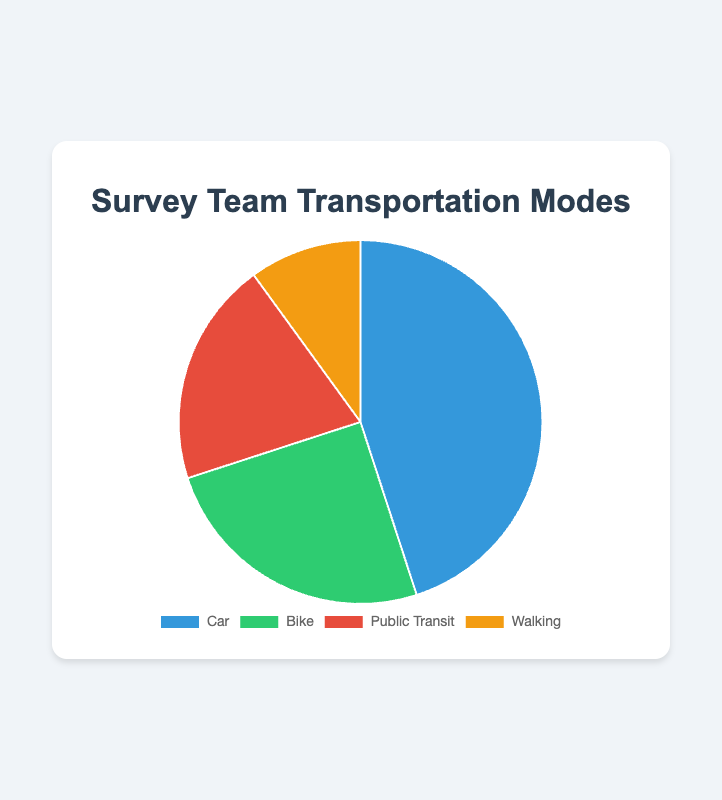What percentage of the survey teams use bicycles or walk for transportation? We need to add the percentages for "Bike" and "Walking". "Bike" accounts for 25% and "Walking" accounts for 10%. Adding these together gives us 25% + 10% = 35%.
Answer: 35% Which mode of transportation is most commonly used by the survey teams? The pie chart shows different modes of transportation with their respective percentages. The highest percentage corresponds to "Car" with 45%.
Answer: Car Are there more survey teams using public transit or walking? We compare the percentages for "Public Transit" and "Walking". "Public Transit" has 20%, while "Walking" has 10%. Since 20% is greater than 10%, more teams use public transit than walking.
Answer: Public Transit How much more popular is using a car compared to using a bike? We need to subtract the percentage of teams using a bike from those using a car. For "Car" it is 45%, and for "Bike" it is 25%. Subtracting these gives us 45% - 25% = 20%.
Answer: 20% more What is the total percentage of survey teams that do not use a car for transportation? We need to add up the percentages for all modes except "Car". The percentages are "Bike" (25%), "Public Transit" (20%), and "Walking" (10%). Adding these together gives us 25% + 20% + 10% = 55%.
Answer: 55% Which segment representing a transportation mode is green in the pie chart? We refer to the color descriptions in the dataset. The segment representing "Bike" is green.
Answer: Bike If we combine "Public Transit" and "Walking", do they together represent a larger proportion than "Bike"? We add the percentages for "Public Transit" and "Walking": 20% + 10% = 30%. Comparing this to "Bike" which is 25%, 30% is indeed larger than 25%.
Answer: Yes What is the ratio of teams using cars to those using public transit? To find the ratio, we divide the percentage for "Car" (45%) by the percentage for "Public Transit" (20%). The ratio is 45% / 20% = 2.25.
Answer: 2.25 Can the number of teams using bikes and walking be considered equal? We compare the percentages for "Bike" and "Walking". "Bike" is 25% and "Walking" is 10%. Since 25% is not equal to 10%, they cannot be considered equal.
Answer: No 